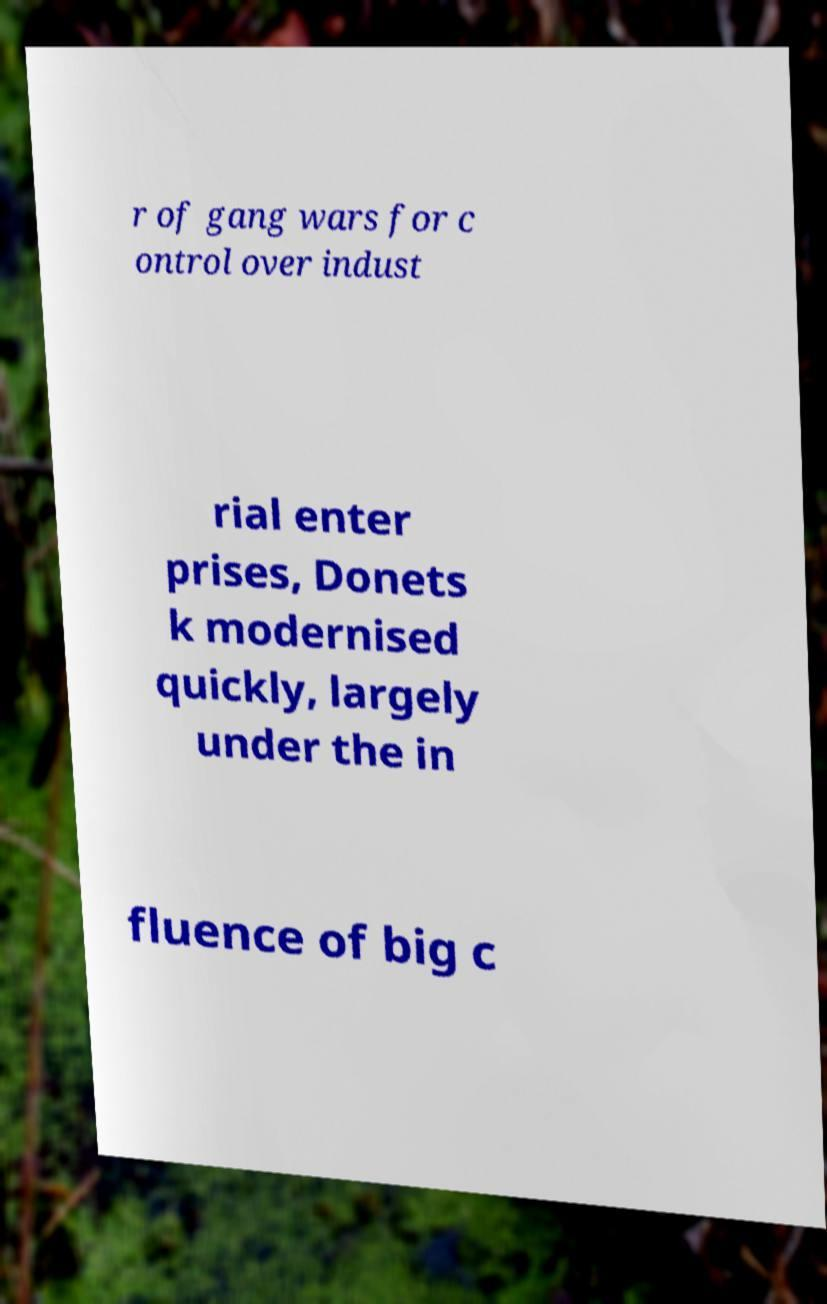Can you read and provide the text displayed in the image?This photo seems to have some interesting text. Can you extract and type it out for me? r of gang wars for c ontrol over indust rial enter prises, Donets k modernised quickly, largely under the in fluence of big c 